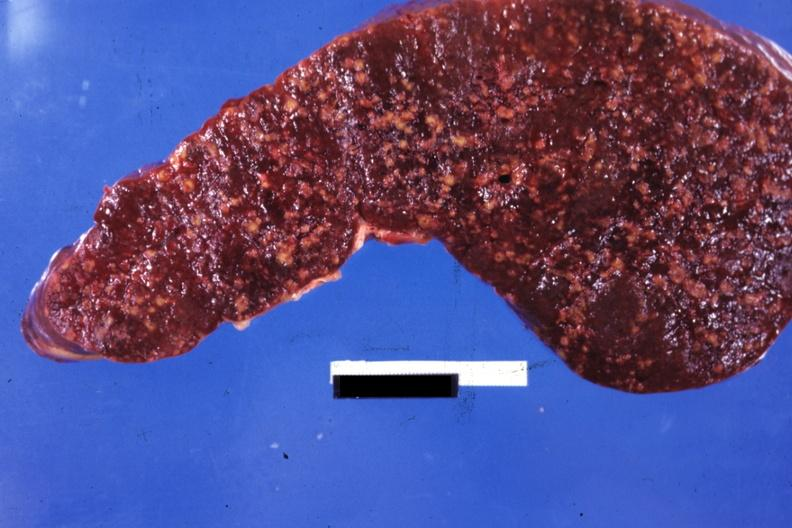what does this image show?
Answer the question using a single word or phrase. Cut surface multiple nodular lesions 